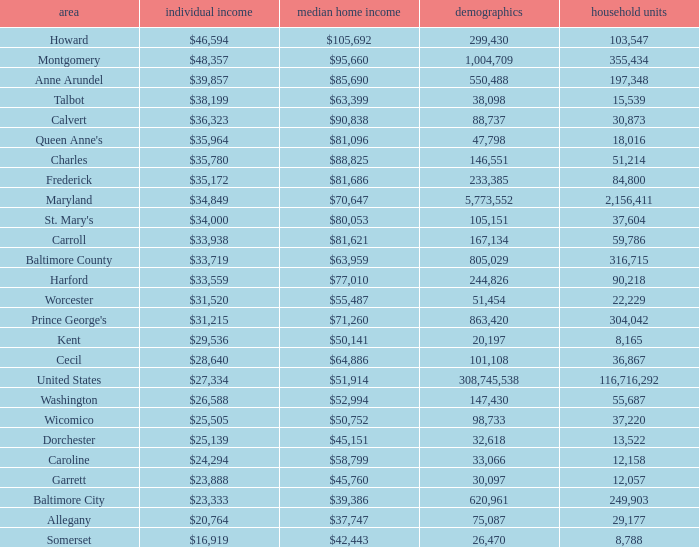What is the per capital income for Washington county? $26,588. 